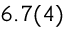Convert formula to latex. <formula><loc_0><loc_0><loc_500><loc_500>6 . 7 ( 4 )</formula> 